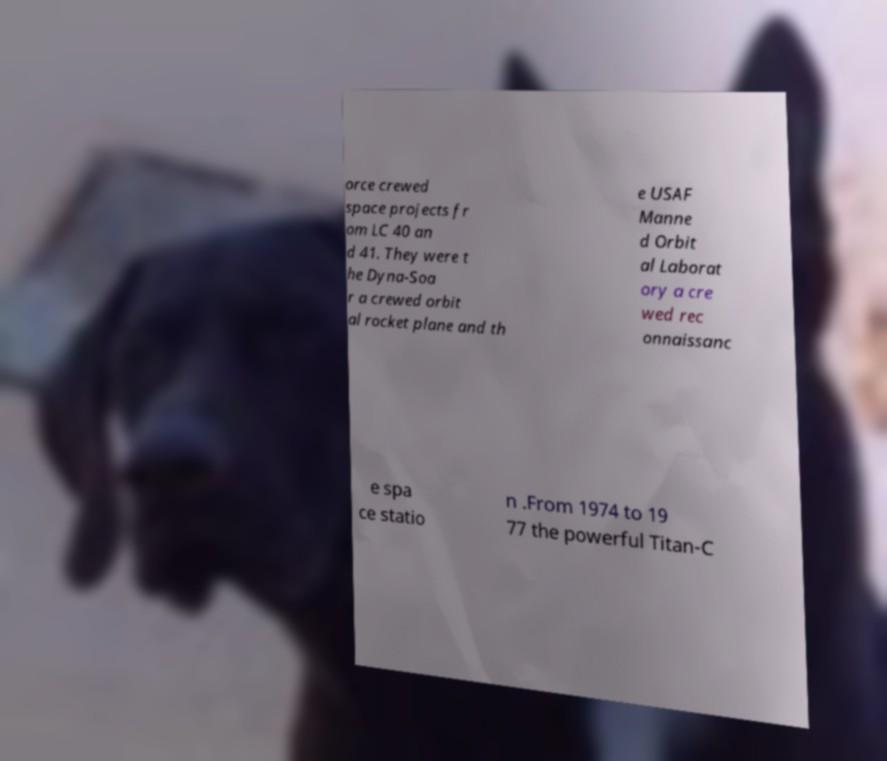Please identify and transcribe the text found in this image. orce crewed space projects fr om LC 40 an d 41. They were t he Dyna-Soa r a crewed orbit al rocket plane and th e USAF Manne d Orbit al Laborat ory a cre wed rec onnaissanc e spa ce statio n .From 1974 to 19 77 the powerful Titan-C 